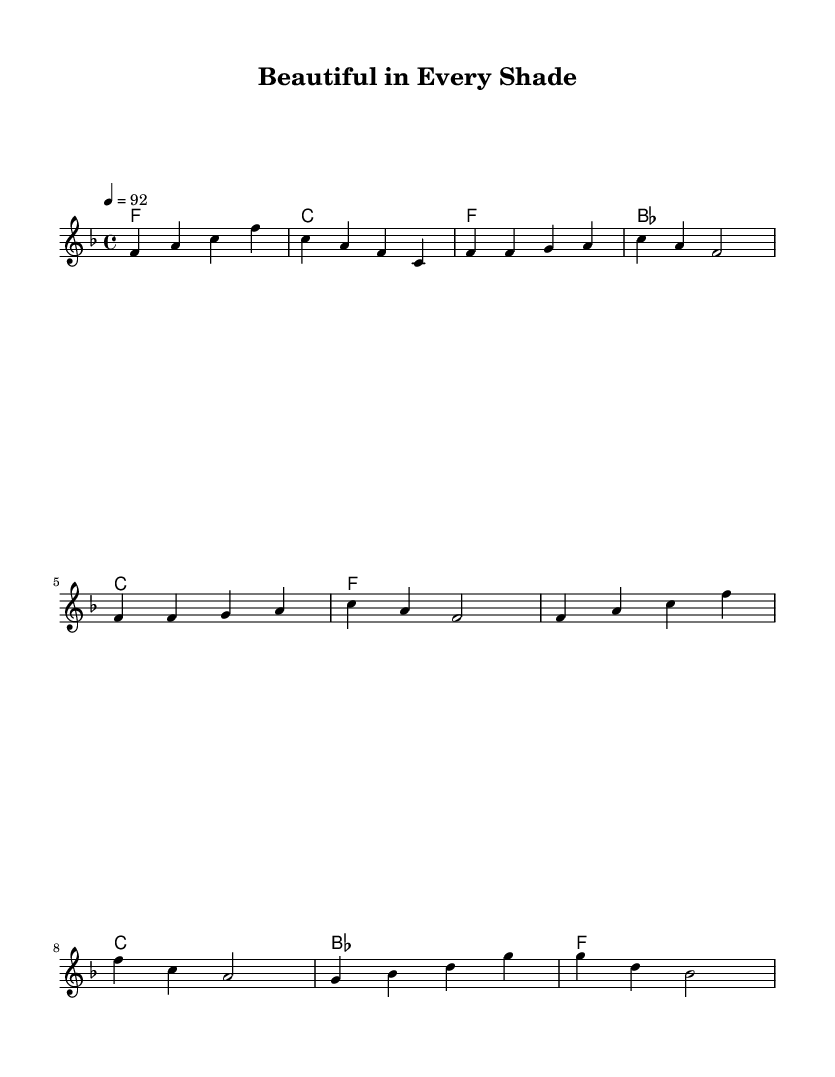What is the key signature of this music? The key signature is F major, which has one flat (B flat). You can find the key signature indicated at the start of the sheet music, showing that F major is the scale used throughout.
Answer: F major What is the time signature of this music? The time signature is 4/4, indicating that there are four beats in each measure and the quarter note gets one beat. This can be found at the beginning of the score, which provides the rhythmic structure of the piece.
Answer: 4/4 What is the tempo marking of the piece? The tempo marking is 92 beats per minute, which is indicated in the score as '4 = 92'. This shows the speed at which the piece should be played.
Answer: 92 How many measures are in the chorus section? The chorus section consists of four measures. This can be confirmed by counting the measures marked in the score under the chorus part: each group of notes is contained within a measure.
Answer: 4 What does the introduction of the piece consist of? The introduction consists of two measures played in a specific pattern of notes (F, A, C, and back to C, A, F), which helps set up the thematic material for the piece. This can be confirmed by examining the first two lines of music in the score.
Answer: 2 measures What style of music is indicated by the title "Beautiful in Every Shade"? The style of music indicated by the title is a fusion of hip-hop and gospel, suggesting themes of empowerment, self-love, and community support. This is inferred from the style mentioned in the question and the emotional tone of the title itself.
Answer: Fusion 